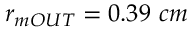<formula> <loc_0><loc_0><loc_500><loc_500>r _ { m O U T } = 0 . 3 9 c m</formula> 